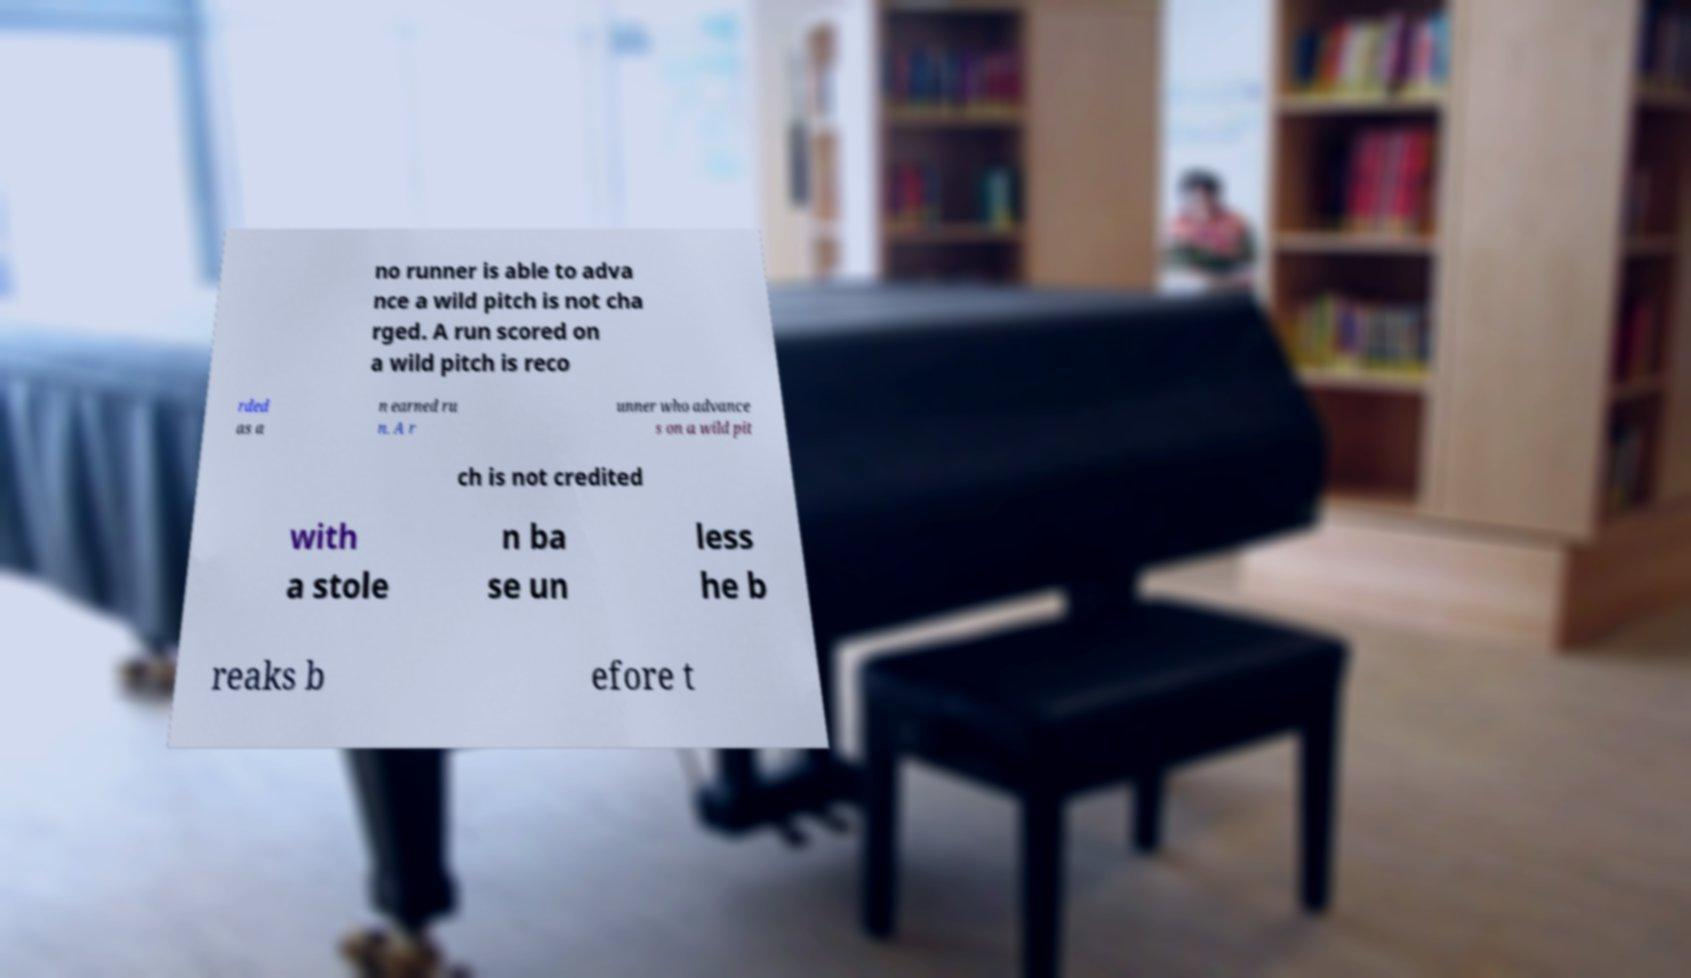Can you accurately transcribe the text from the provided image for me? no runner is able to adva nce a wild pitch is not cha rged. A run scored on a wild pitch is reco rded as a n earned ru n. A r unner who advance s on a wild pit ch is not credited with a stole n ba se un less he b reaks b efore t 